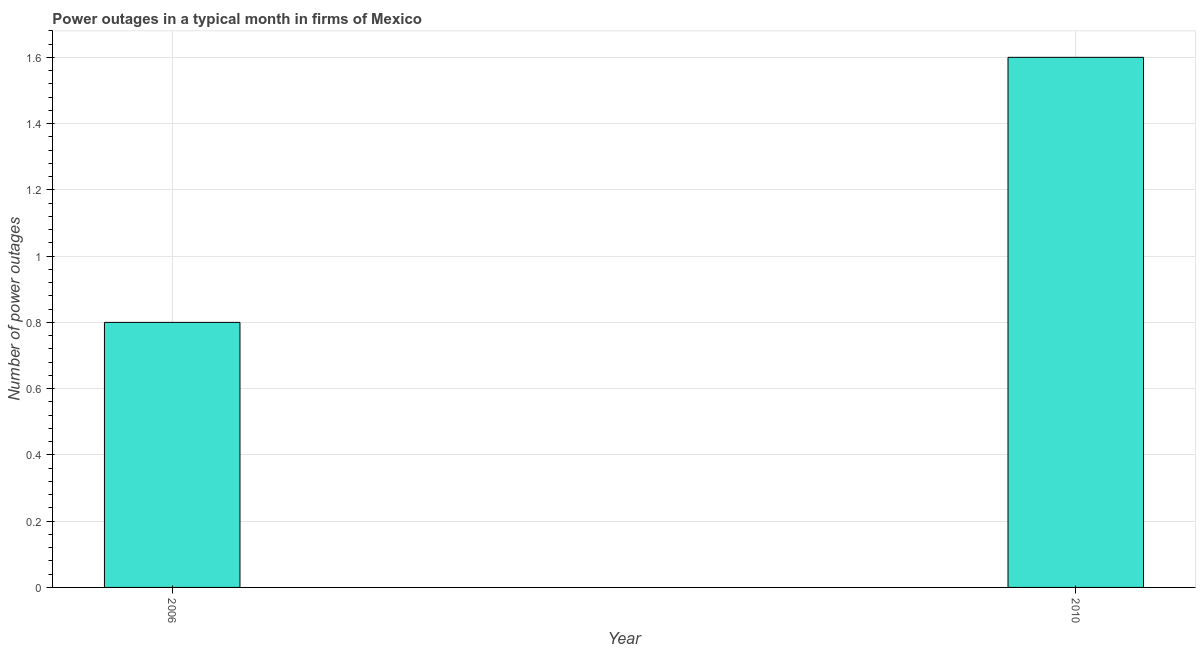Does the graph contain any zero values?
Your answer should be very brief. No. Does the graph contain grids?
Provide a short and direct response. Yes. What is the title of the graph?
Provide a succinct answer. Power outages in a typical month in firms of Mexico. What is the label or title of the Y-axis?
Provide a succinct answer. Number of power outages. What is the number of power outages in 2010?
Keep it short and to the point. 1.6. In which year was the number of power outages maximum?
Provide a succinct answer. 2010. In which year was the number of power outages minimum?
Your answer should be very brief. 2006. What is the sum of the number of power outages?
Your answer should be compact. 2.4. What is the difference between the number of power outages in 2006 and 2010?
Provide a succinct answer. -0.8. What is the average number of power outages per year?
Make the answer very short. 1.2. What is the median number of power outages?
Give a very brief answer. 1.2. In how many years, is the number of power outages greater than 0.6 ?
Provide a succinct answer. 2. Do a majority of the years between 2006 and 2010 (inclusive) have number of power outages greater than 0.04 ?
Your answer should be compact. Yes. Is the number of power outages in 2006 less than that in 2010?
Offer a terse response. Yes. In how many years, is the number of power outages greater than the average number of power outages taken over all years?
Provide a succinct answer. 1. How many bars are there?
Provide a short and direct response. 2. Are all the bars in the graph horizontal?
Make the answer very short. No. How many years are there in the graph?
Offer a very short reply. 2. What is the difference between two consecutive major ticks on the Y-axis?
Ensure brevity in your answer.  0.2. Are the values on the major ticks of Y-axis written in scientific E-notation?
Provide a short and direct response. No. What is the Number of power outages of 2006?
Provide a short and direct response. 0.8. What is the Number of power outages in 2010?
Offer a very short reply. 1.6. What is the difference between the Number of power outages in 2006 and 2010?
Make the answer very short. -0.8. What is the ratio of the Number of power outages in 2006 to that in 2010?
Offer a very short reply. 0.5. 